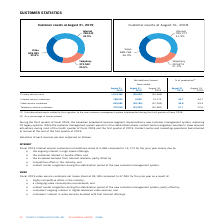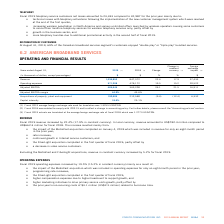According to Cogeco's financial document, How many legacy systems were replaced by implementing the new customer management system? According to the financial document, 22. The relevant text states: "service customers 372,540 (23,333) (32,987) 21.1 22.6..." Also, What were the net additions of the internet customers in 2019? According to the financial document, 5,966. The relevant text states: "Internet service customers 788,243 5,966 14,173 44.7 44.7..." Also, What was the net loss for video customers in 2019? According to the financial document, 39,185. The relevant text states: "Video service customers 649,583 (39,185) (37,035) 36.8 39.3..." Also, can you calculate: What was the increase / (decrease) in the net additions of Primary service units in 2019 from 2018? Based on the calculation: -56,552 - (-55,849), the result is -703. This is based on the information: "Primary service units 1,810,366 (56,552) (55,849) Primary service units 1,810,366 (56,552) (55,849)..." The key data points involved are: 55,849, 56,552. Also, can you calculate: What was the average increase / (decrease) in the internet service customers between 2018 and 2019? To answer this question, I need to perform calculations using the financial data. The calculation is: (5,966 + 14,173) / 2, which equals 10069.5. This is based on the information: "Internet service customers 788,243 5,966 14,173 44.7 44.7 Internet service customers 788,243 5,966 14,173 44.7 44.7..." The key data points involved are: 14,173, 5,966. Also, can you calculate: What was the average increase / (decrease) in video service customers between 2018 and 2019? To answer this question, I need to perform calculations using the financial data. The calculation is: -(39,185 + 37,035) / 2, which equals -38110. This is based on the information: "Video service customers 649,583 (39,185) (37,035) 36.8 39.3 Video service customers 649,583 (39,185) (37,035) 36.8 39.3..." The key data points involved are: 37,035, 39,185. 